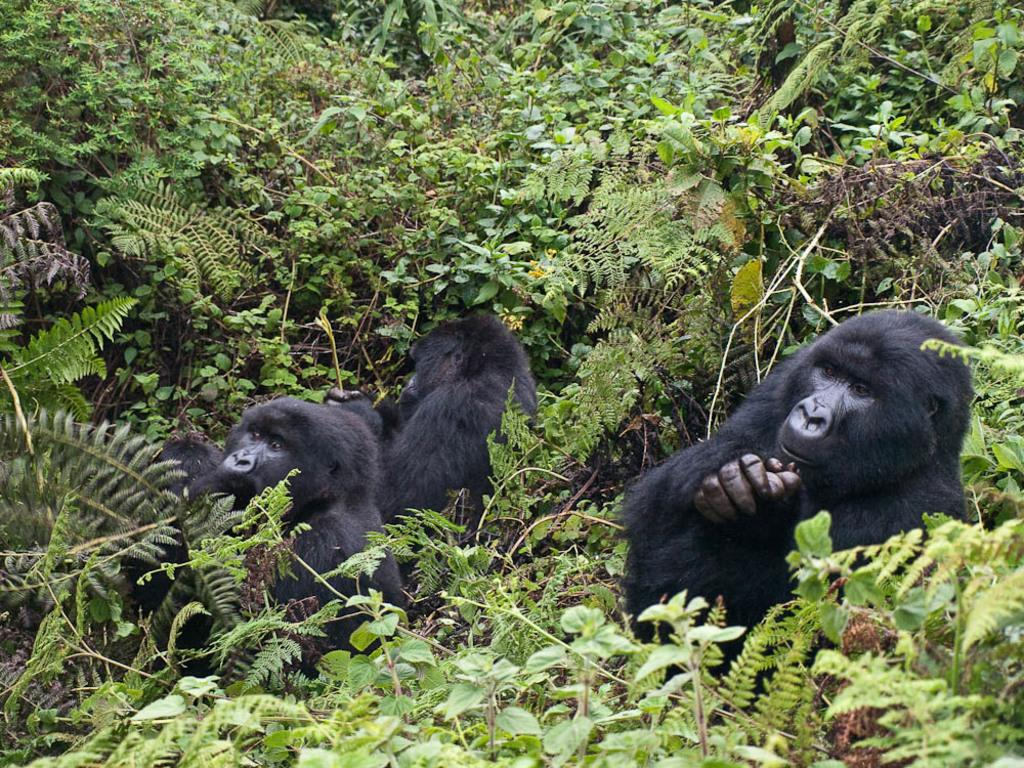What is the possible location of the image? The image might be taken from a forest. How many animals can be seen in the image? There are two animals in the middle of the image. What can be seen in the background of the image? There are trees and plants in the background of the image. What color is the vein visible on one of the animals in the image? There is no vein visible on any of the animals in the image. How many pigs are involved in the image? There are no pigs present in the image. 